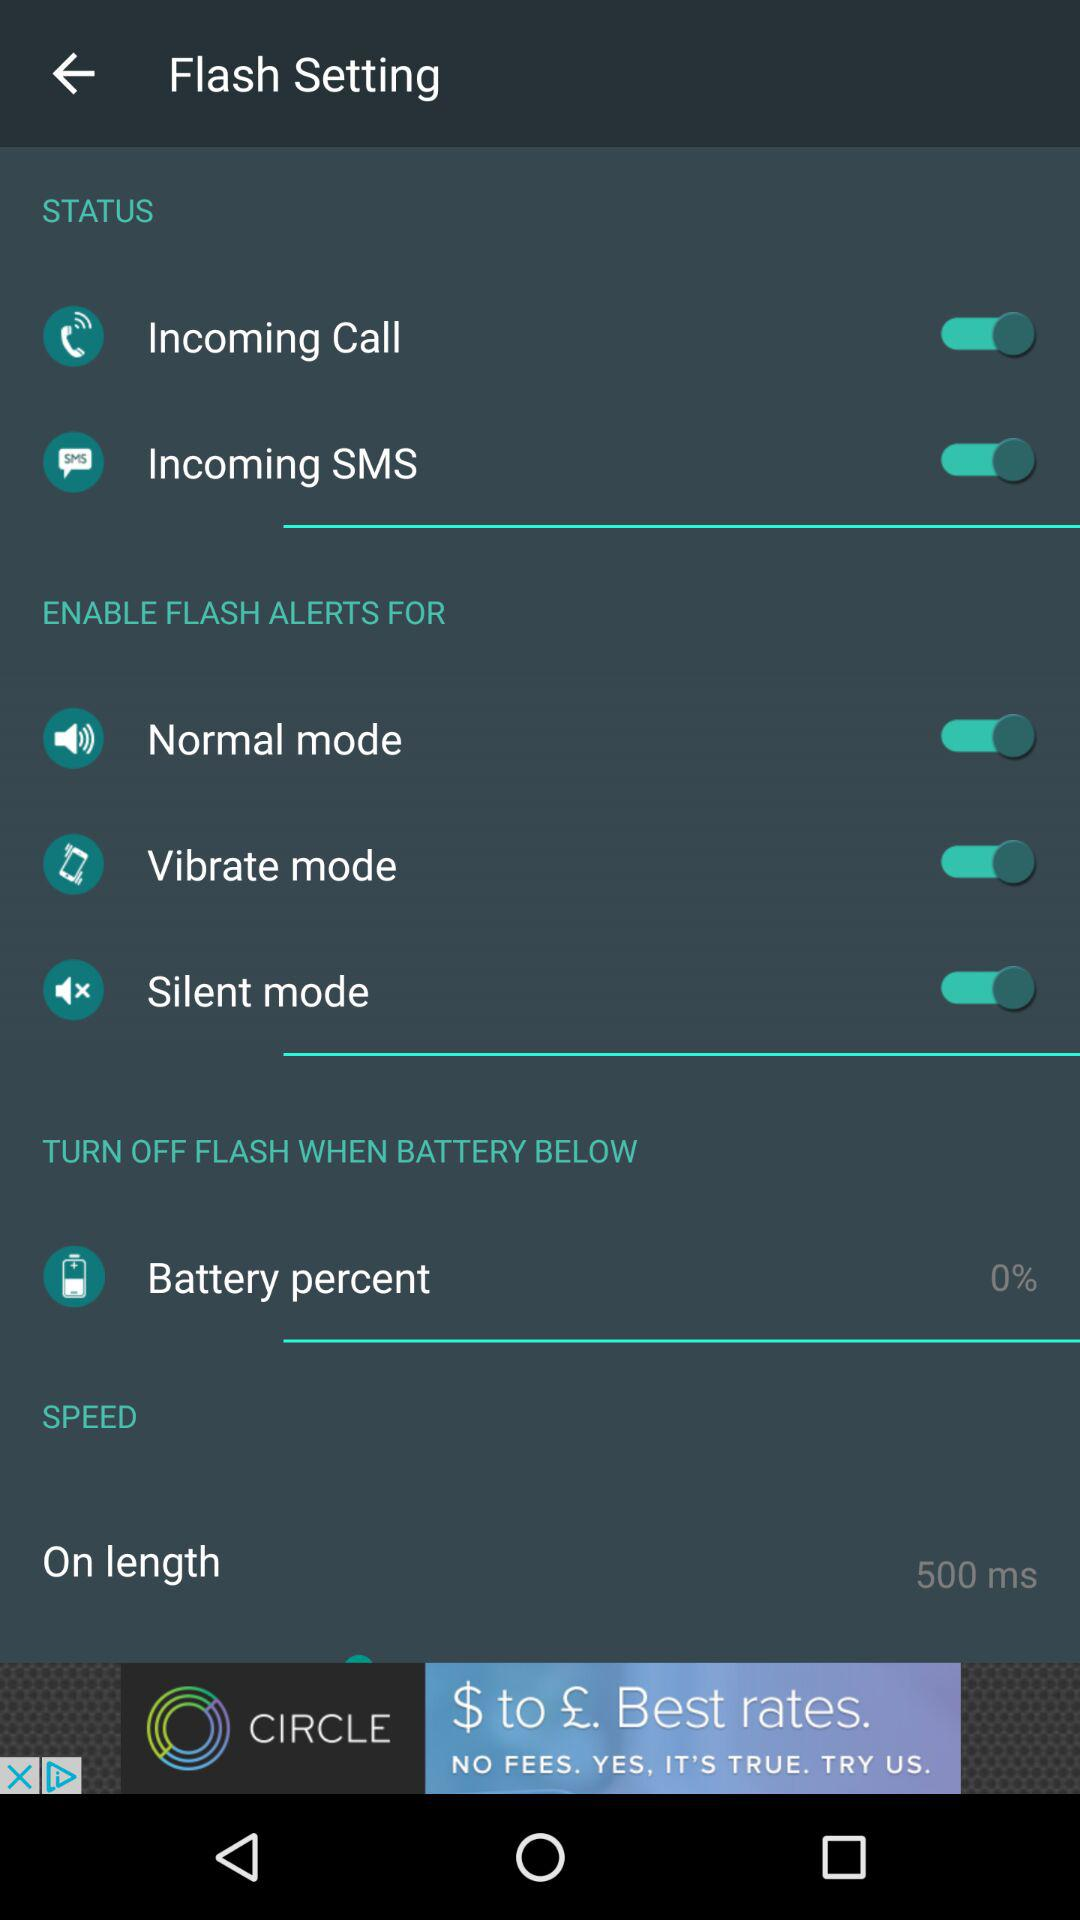At what percentage of the battery will the flash be turned off? The flash will be turned off when the battery is below 0. 